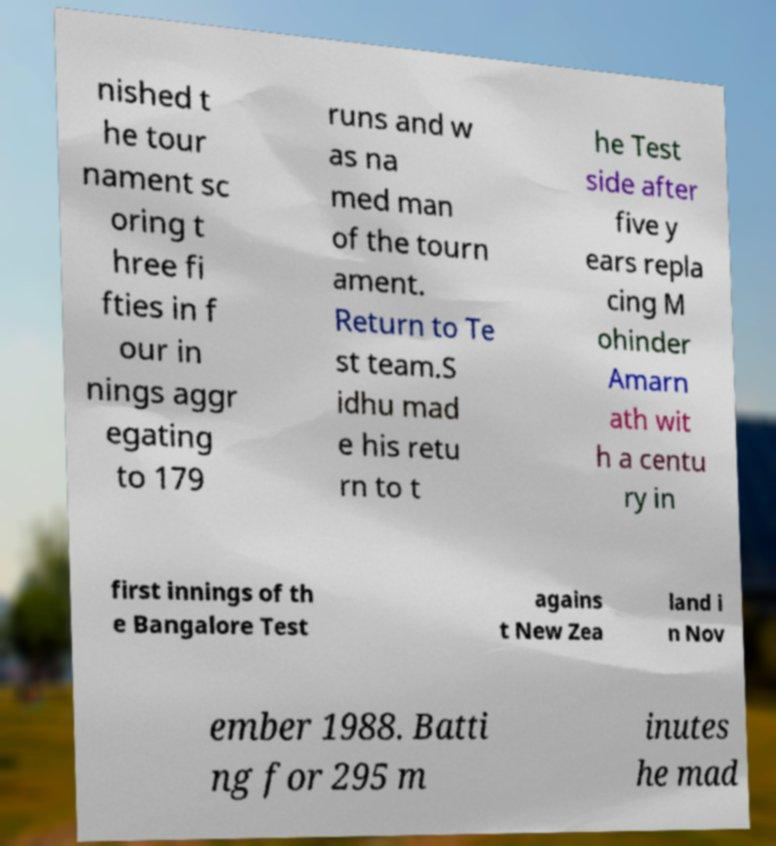What messages or text are displayed in this image? I need them in a readable, typed format. nished t he tour nament sc oring t hree fi fties in f our in nings aggr egating to 179 runs and w as na med man of the tourn ament. Return to Te st team.S idhu mad e his retu rn to t he Test side after five y ears repla cing M ohinder Amarn ath wit h a centu ry in first innings of th e Bangalore Test agains t New Zea land i n Nov ember 1988. Batti ng for 295 m inutes he mad 